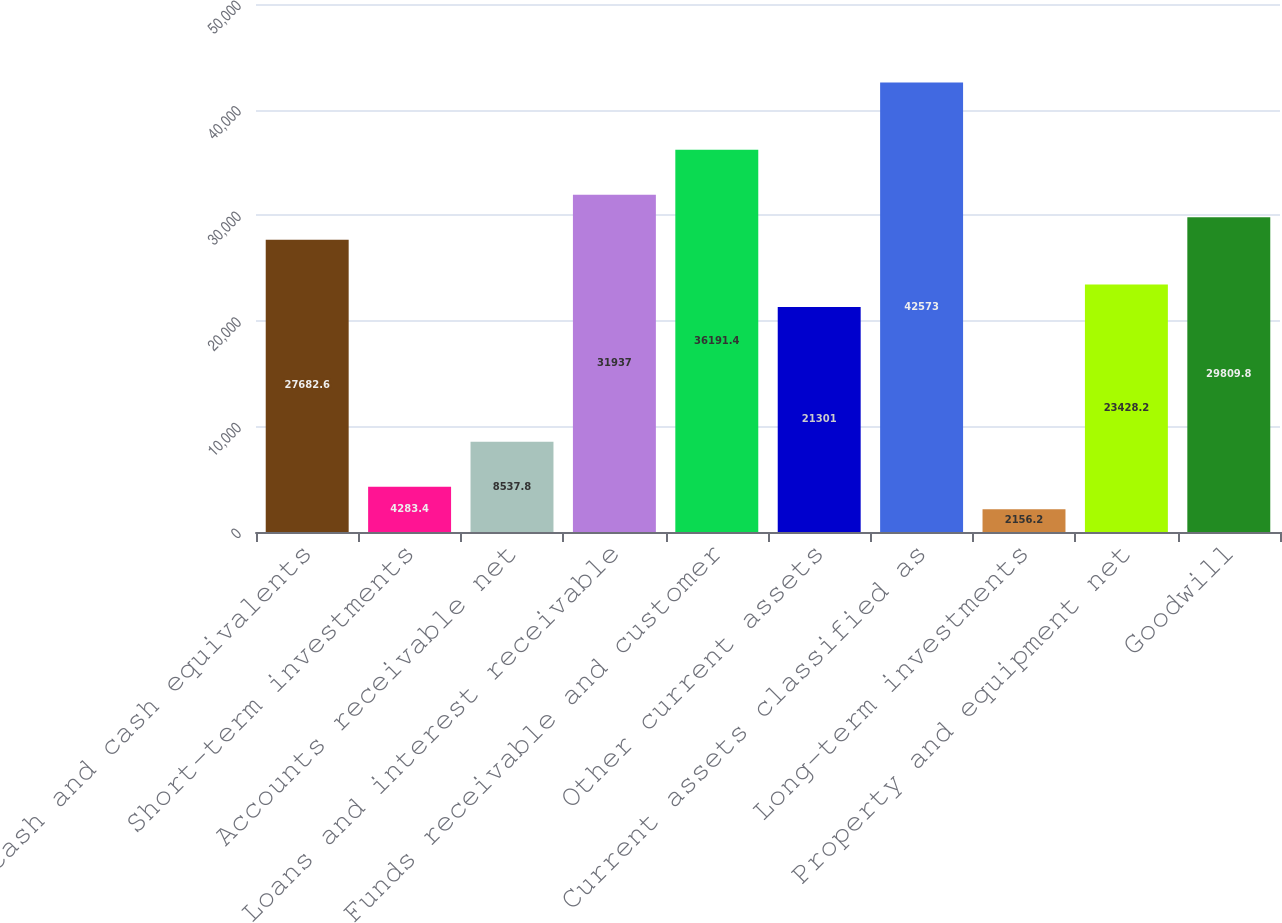<chart> <loc_0><loc_0><loc_500><loc_500><bar_chart><fcel>Cash and cash equivalents<fcel>Short-term investments<fcel>Accounts receivable net<fcel>Loans and interest receivable<fcel>Funds receivable and customer<fcel>Other current assets<fcel>Current assets classified as<fcel>Long-term investments<fcel>Property and equipment net<fcel>Goodwill<nl><fcel>27682.6<fcel>4283.4<fcel>8537.8<fcel>31937<fcel>36191.4<fcel>21301<fcel>42573<fcel>2156.2<fcel>23428.2<fcel>29809.8<nl></chart> 